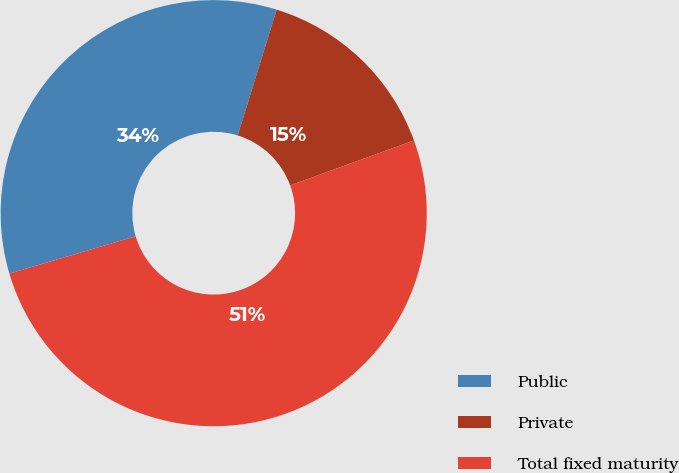<chart> <loc_0><loc_0><loc_500><loc_500><pie_chart><fcel>Public<fcel>Private<fcel>Total fixed maturity<nl><fcel>34.35%<fcel>14.68%<fcel>50.97%<nl></chart> 